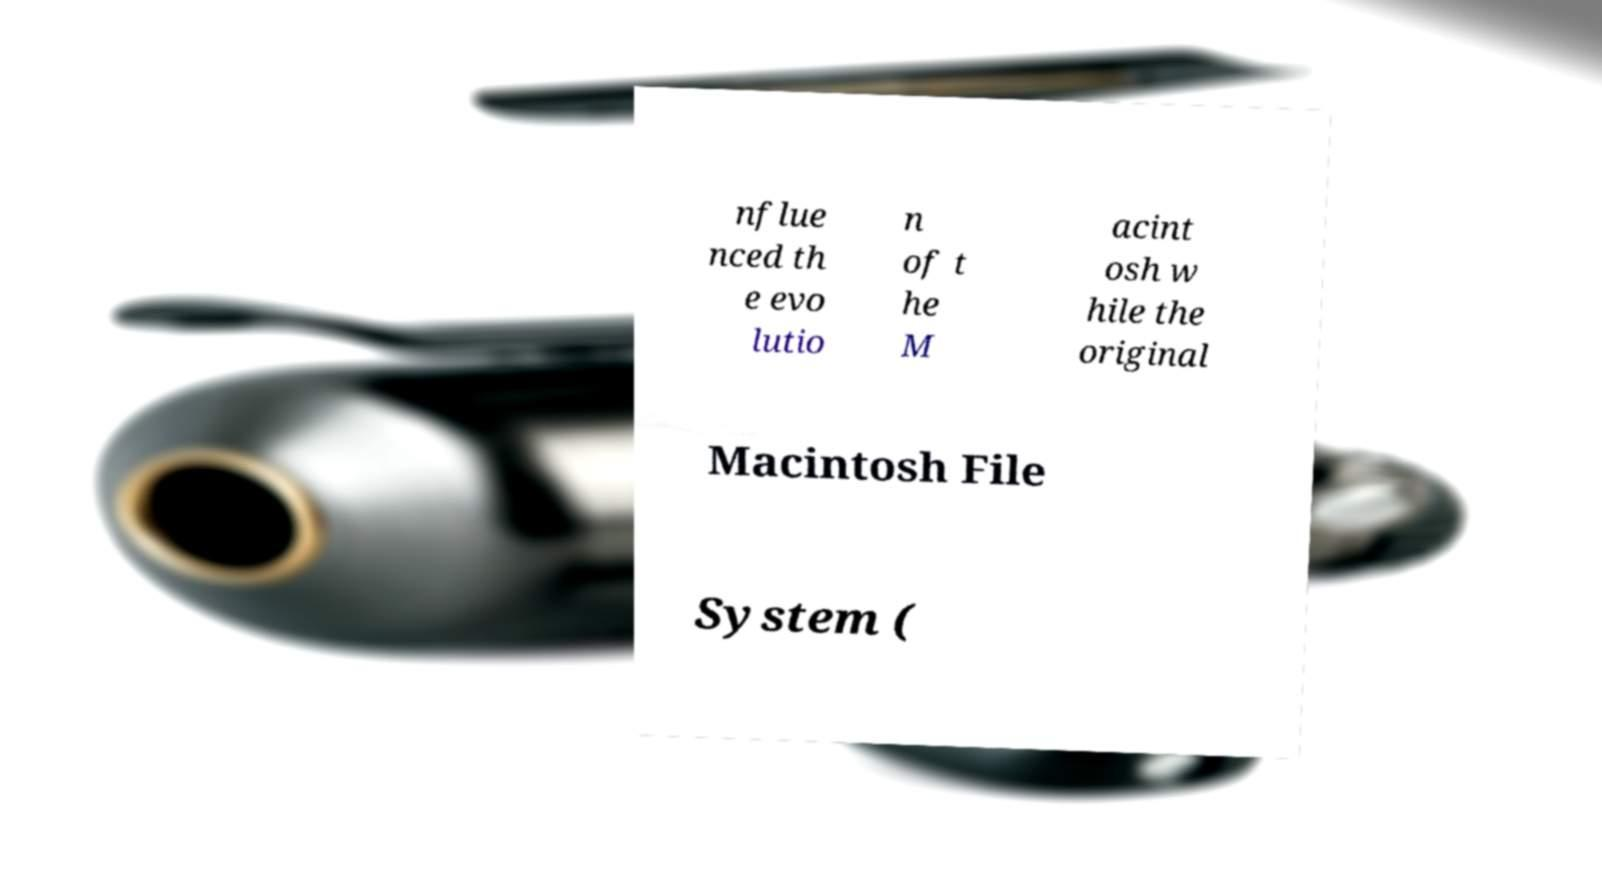Could you extract and type out the text from this image? nflue nced th e evo lutio n of t he M acint osh w hile the original Macintosh File System ( 